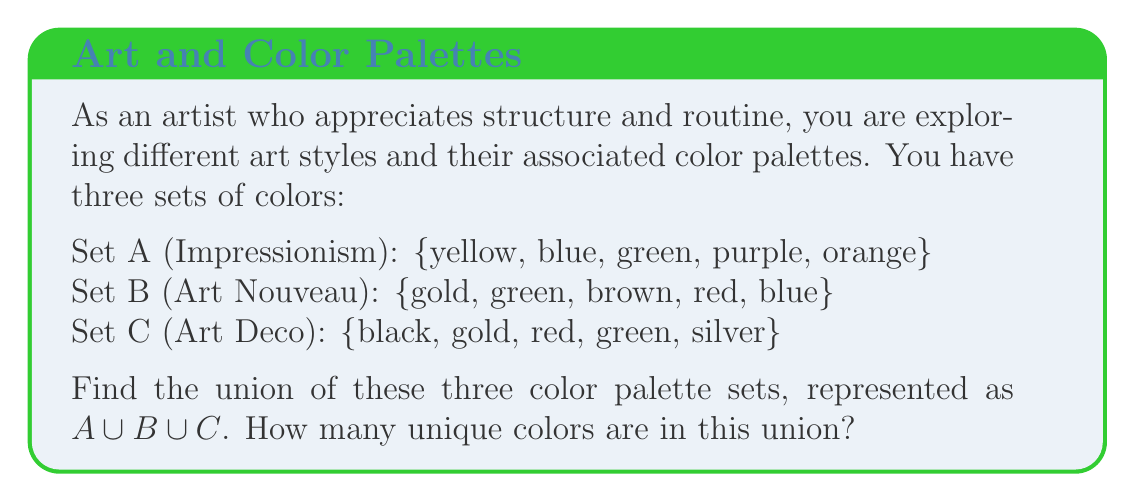Help me with this question. To find the union of these three sets, we need to combine all unique elements from each set. Let's approach this step-by-step:

1. First, let's list all the colors from each set:
   Set A: yellow, blue, green, purple, orange
   Set B: gold, green, brown, red, blue
   Set C: black, gold, red, green, silver

2. Now, let's combine these sets and eliminate duplicates:
   $A \cup B \cup C = \{$yellow, blue, green, purple, orange, gold, brown, red, black, silver$\}$

3. Let's count the unique colors:
   1. yellow
   2. blue
   3. green
   4. purple
   5. orange
   6. gold
   7. brown
   8. red
   9. black
   10. silver

Therefore, there are 10 unique colors in the union of these three color palette sets.

This structured approach aligns with your preference for routine and predictability in your artistic process, allowing you to systematically analyze and combine color palettes from different art styles.
Answer: The union of the three color palette sets contains 10 unique colors. 